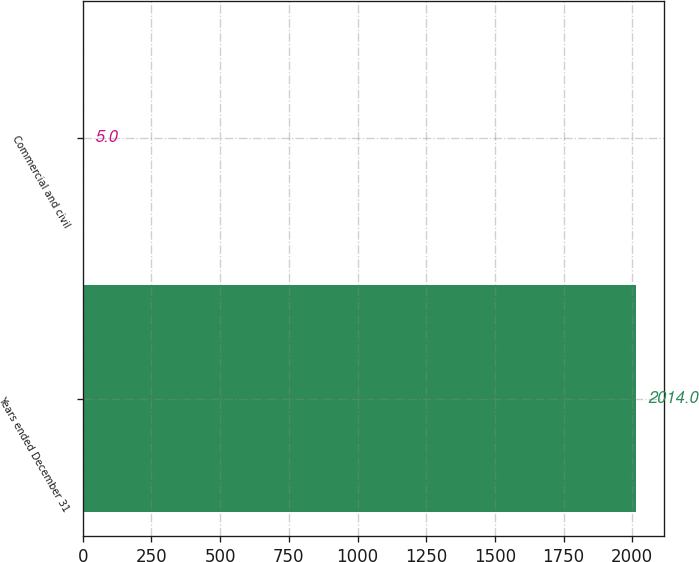Convert chart to OTSL. <chart><loc_0><loc_0><loc_500><loc_500><bar_chart><fcel>Years ended December 31<fcel>Commercial and civil<nl><fcel>2014<fcel>5<nl></chart> 